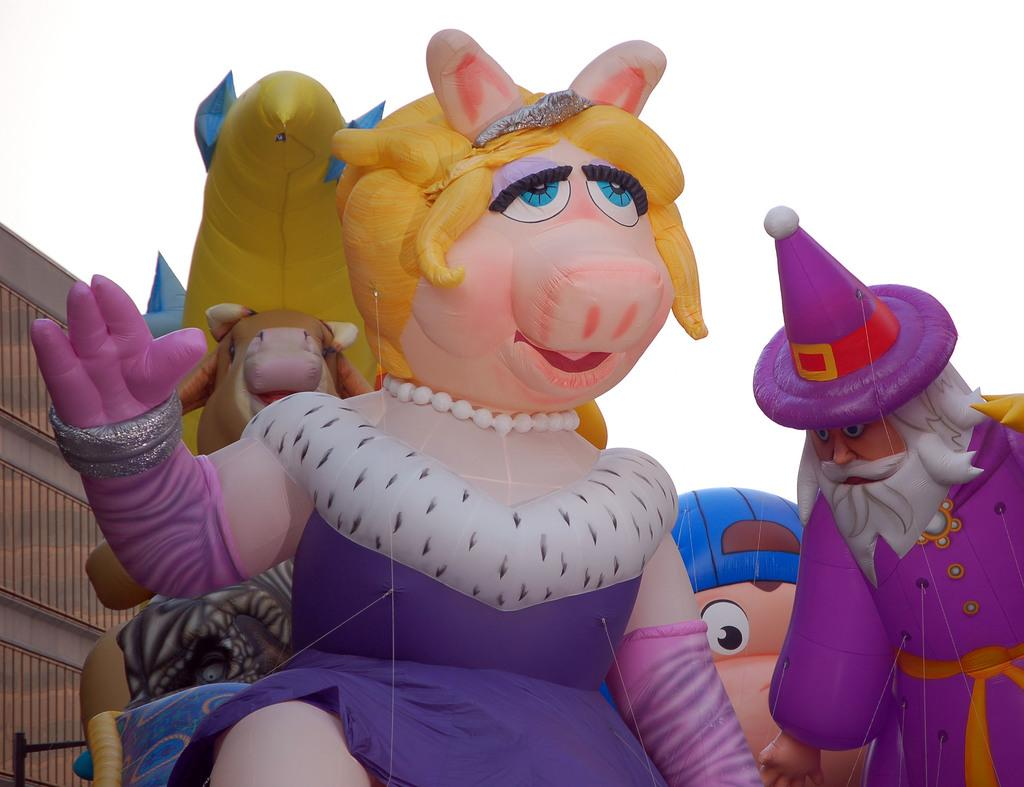What is the main subject of the image? There are colorful toys in the center of the image. What can be seen in the background of the image? The sky is visible in the background of the image. Are there any other objects present in the background? Yes, there are other objects present in the background of the image. What type of pie is being served in the image? There is no pie present in the image; it features colorful toys and a background with the sky and other objects. 